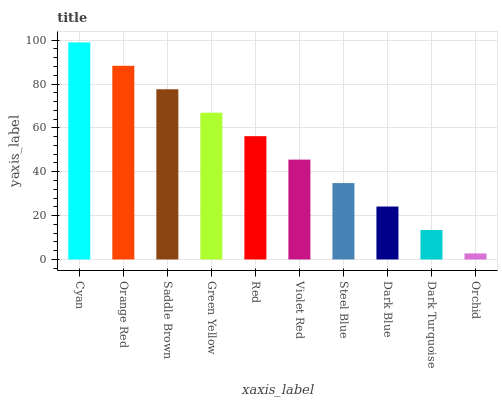Is Orchid the minimum?
Answer yes or no. Yes. Is Cyan the maximum?
Answer yes or no. Yes. Is Orange Red the minimum?
Answer yes or no. No. Is Orange Red the maximum?
Answer yes or no. No. Is Cyan greater than Orange Red?
Answer yes or no. Yes. Is Orange Red less than Cyan?
Answer yes or no. Yes. Is Orange Red greater than Cyan?
Answer yes or no. No. Is Cyan less than Orange Red?
Answer yes or no. No. Is Red the high median?
Answer yes or no. Yes. Is Violet Red the low median?
Answer yes or no. Yes. Is Dark Turquoise the high median?
Answer yes or no. No. Is Steel Blue the low median?
Answer yes or no. No. 